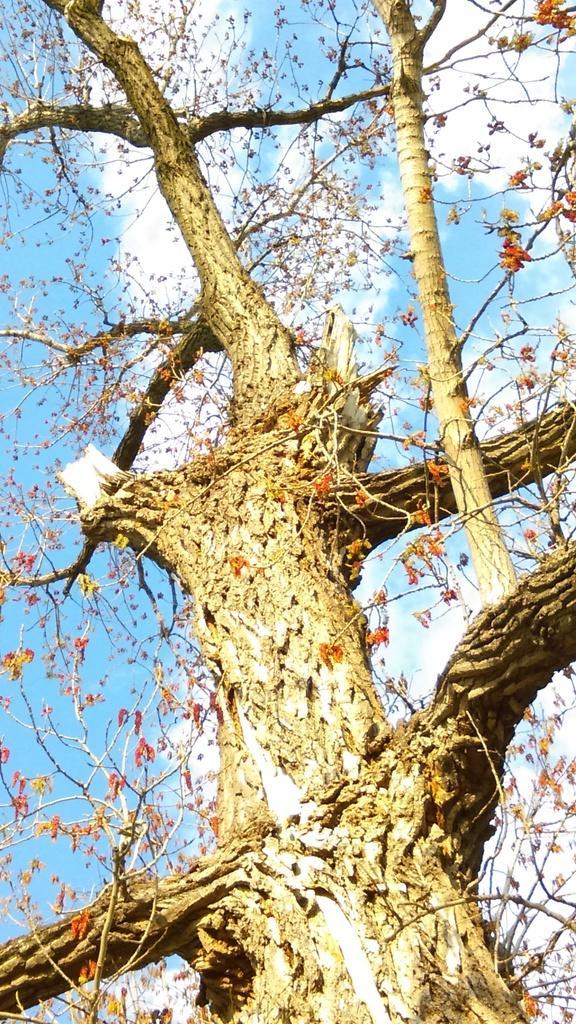Describe this image in one or two sentences. In this picture we can see tree and flowers. In the background of the image we can see the sky with clouds. 